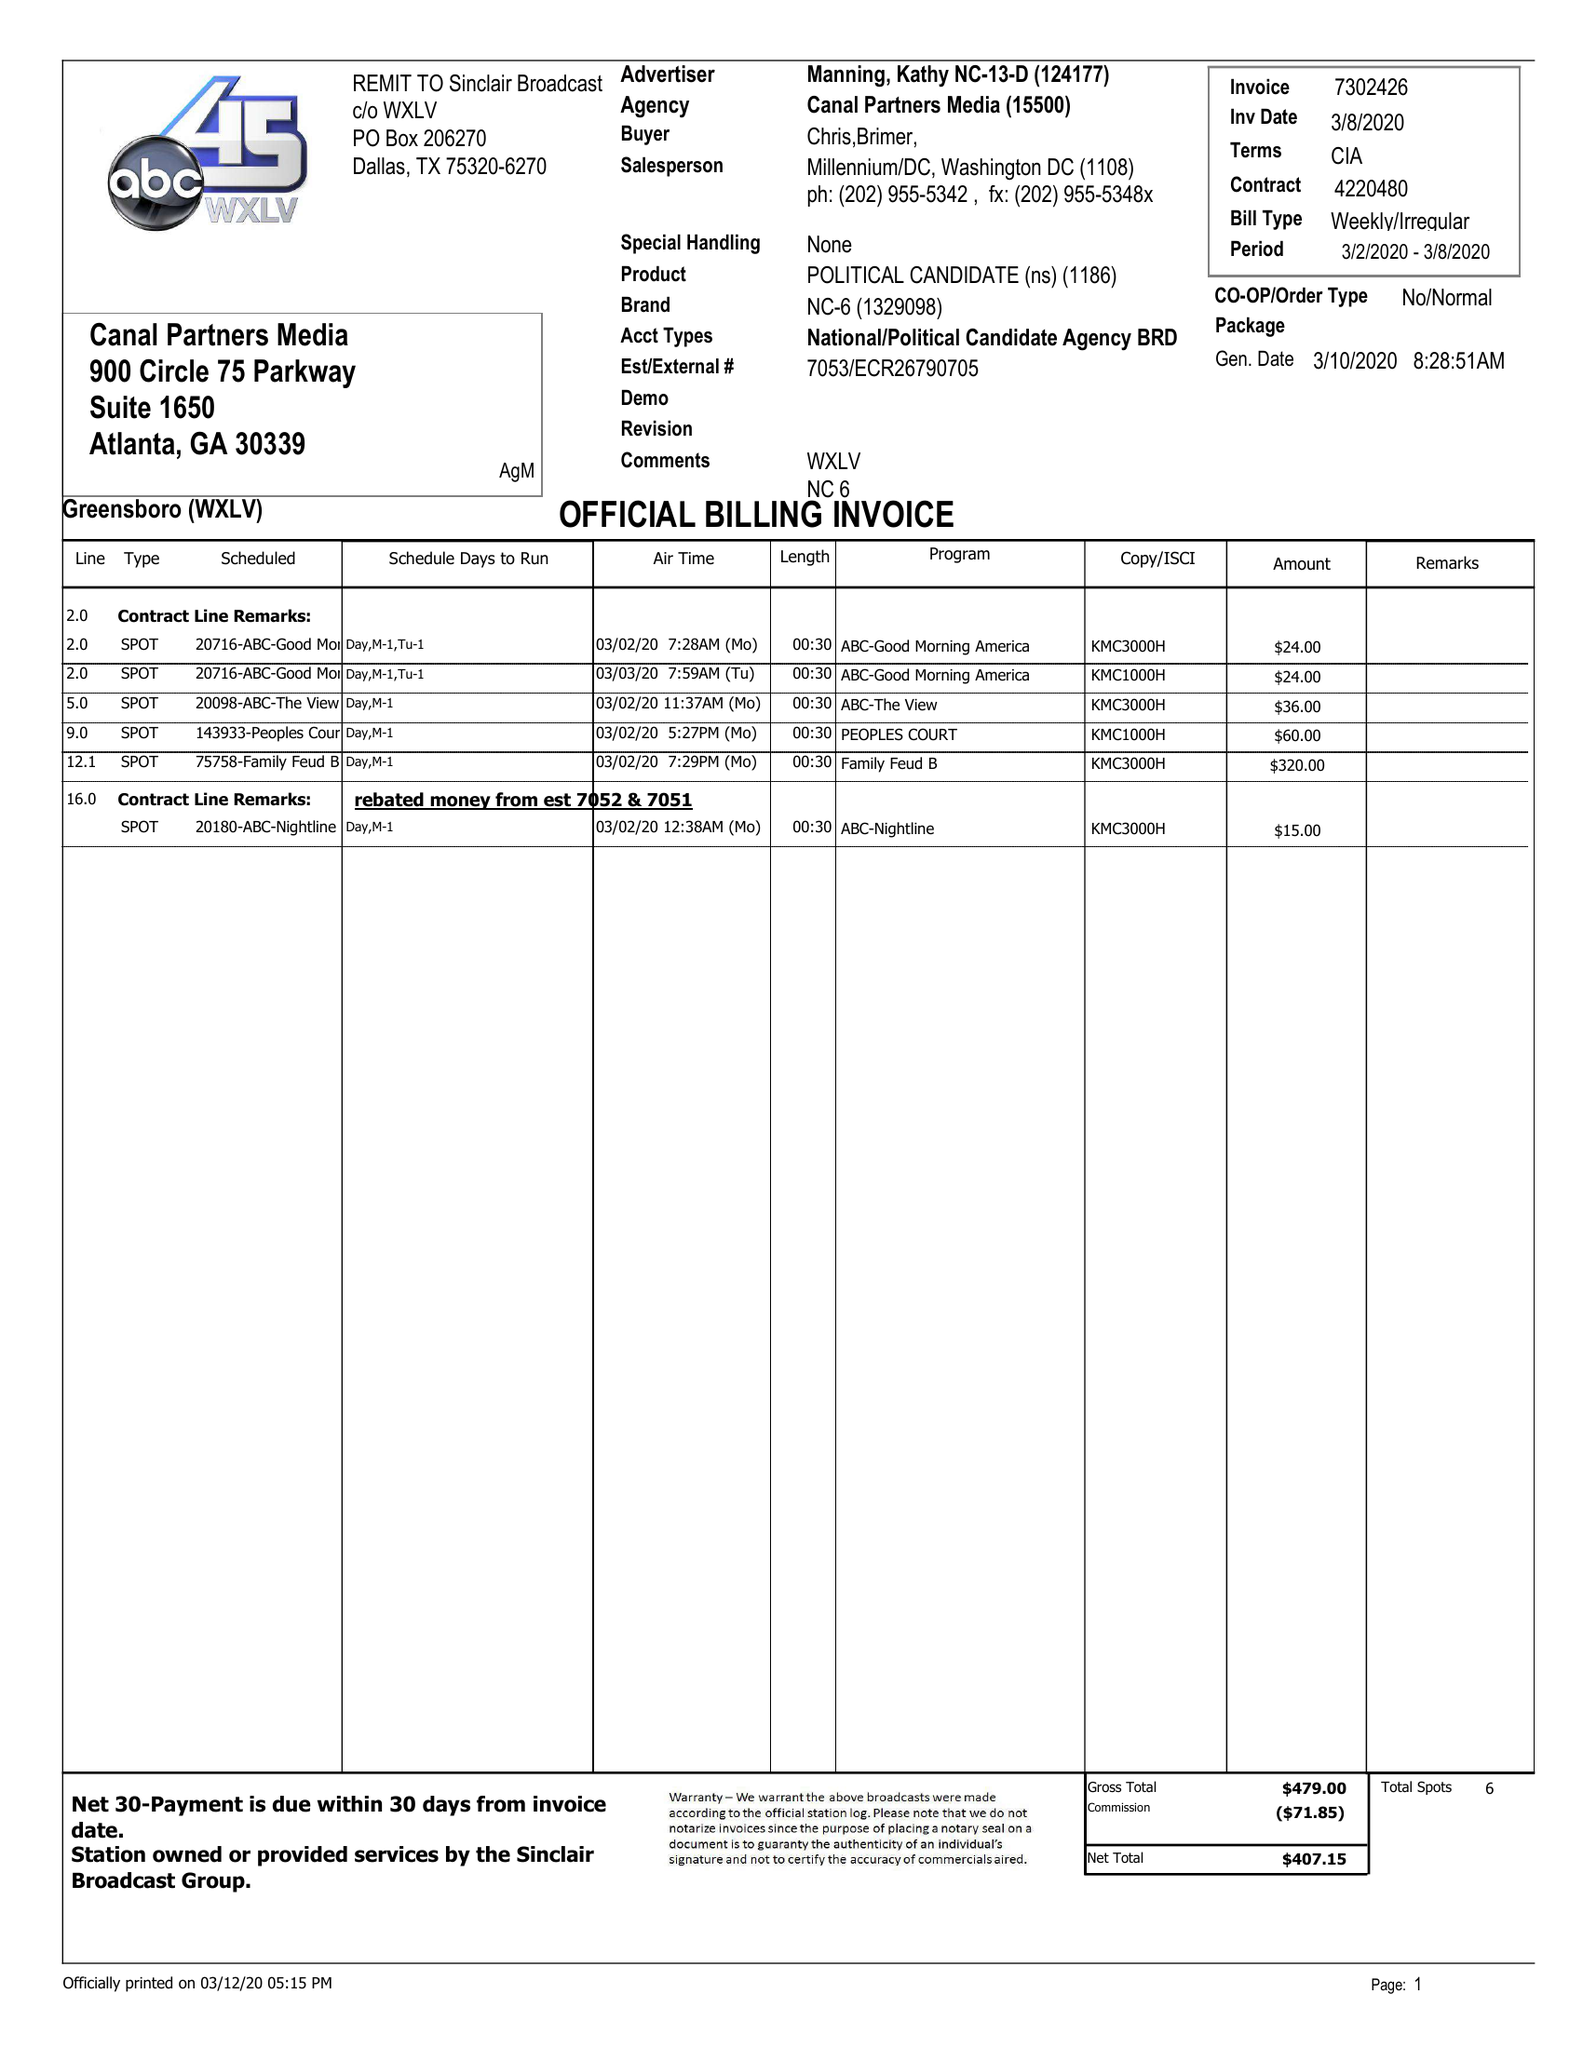What is the value for the flight_to?
Answer the question using a single word or phrase. 03/08/20 